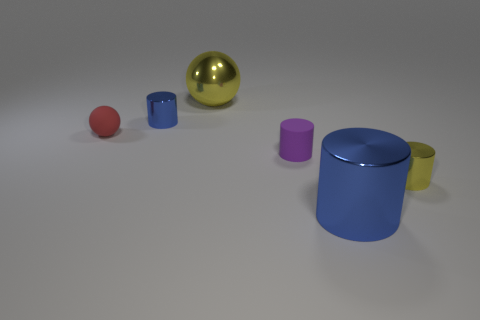What is the color of the matte object that is the same shape as the big blue metallic object?
Offer a very short reply. Purple. Is the material of the tiny ball the same as the small purple thing that is behind the big blue thing?
Your answer should be very brief. Yes. The yellow thing behind the yellow thing in front of the large yellow shiny sphere is what shape?
Provide a short and direct response. Sphere. There is a blue cylinder that is to the right of the purple cylinder; does it have the same size as the purple thing?
Your answer should be compact. No. How many other objects are the same shape as the large yellow thing?
Offer a very short reply. 1. There is a cylinder that is behind the small rubber ball; is its color the same as the big cylinder?
Provide a succinct answer. Yes. Is there another shiny cylinder of the same color as the large cylinder?
Offer a terse response. Yes. What number of blue cylinders are behind the small yellow cylinder?
Provide a short and direct response. 1. How many other things are there of the same size as the yellow metal cylinder?
Make the answer very short. 3. Do the sphere in front of the small blue metallic cylinder and the blue cylinder that is in front of the tiny red rubber object have the same material?
Offer a very short reply. No. 